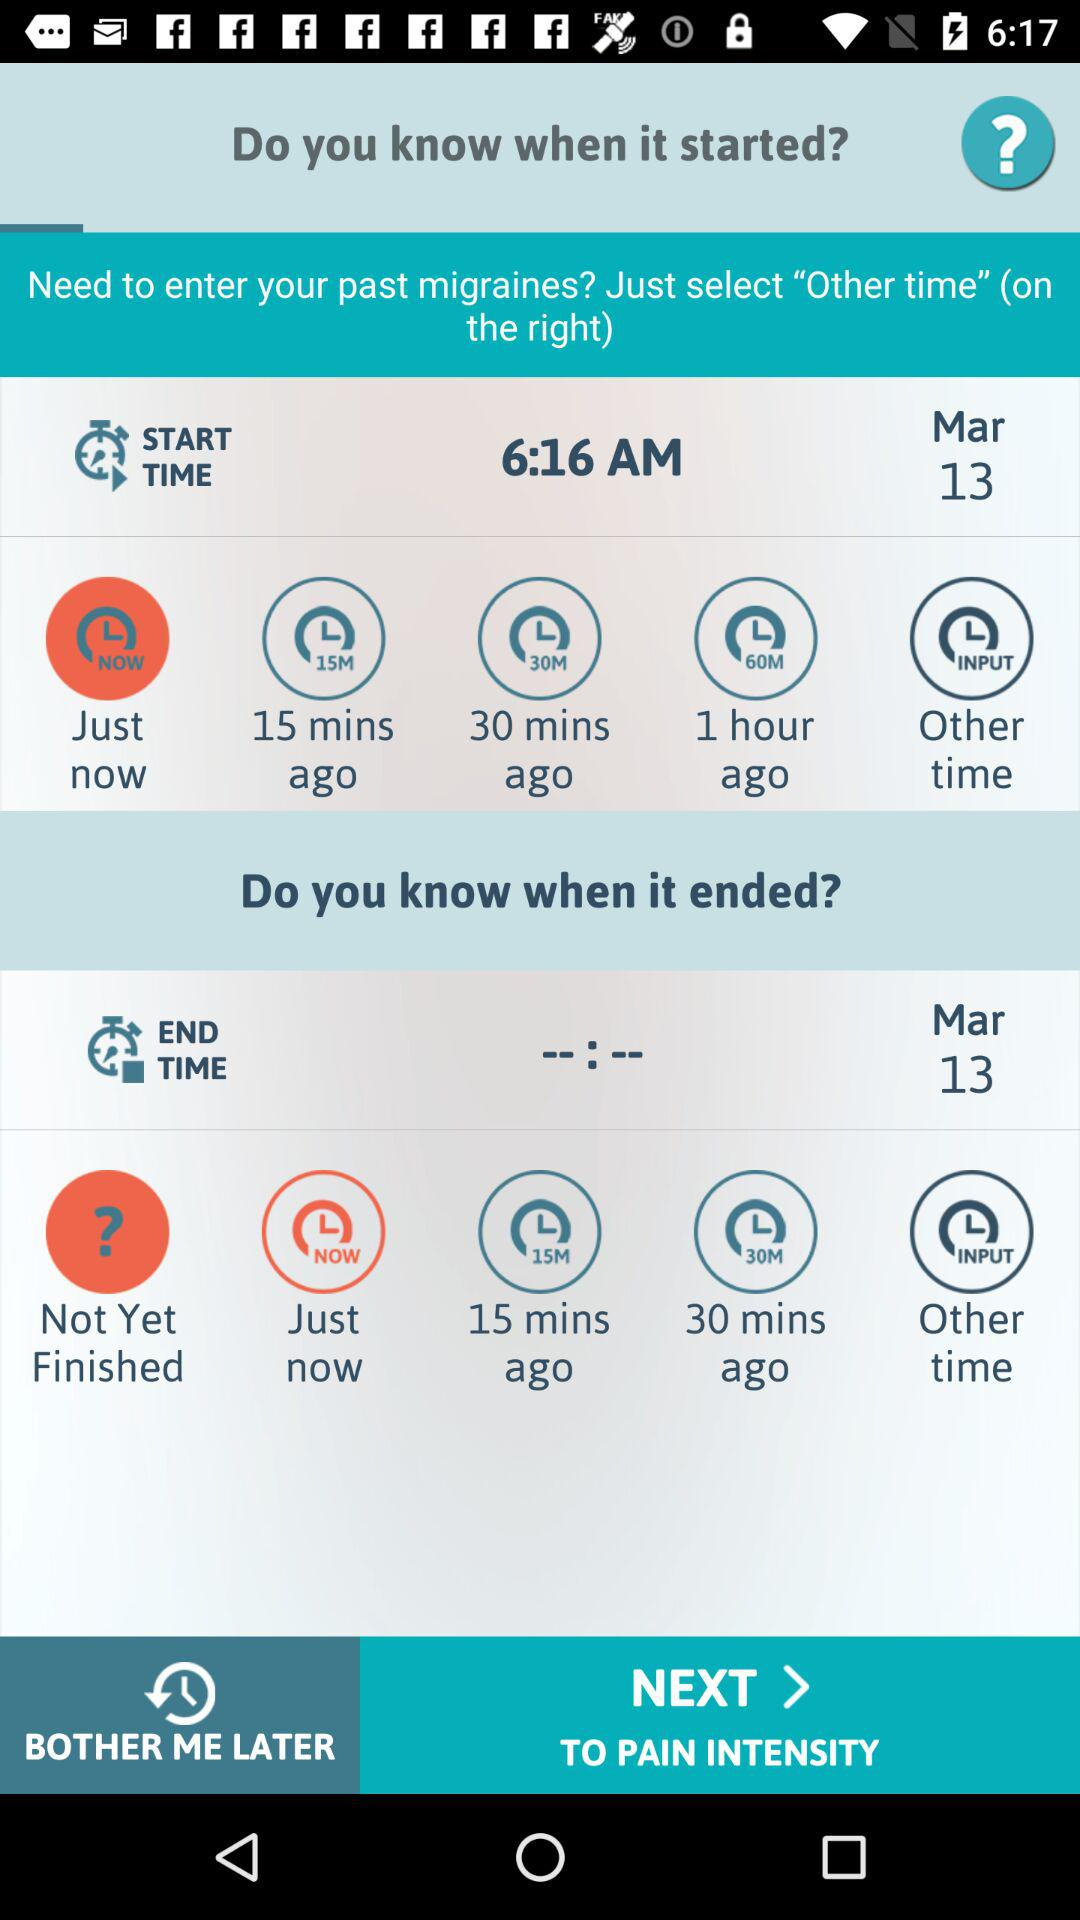What is the end time?
When the provided information is insufficient, respond with <no answer>. <no answer> 